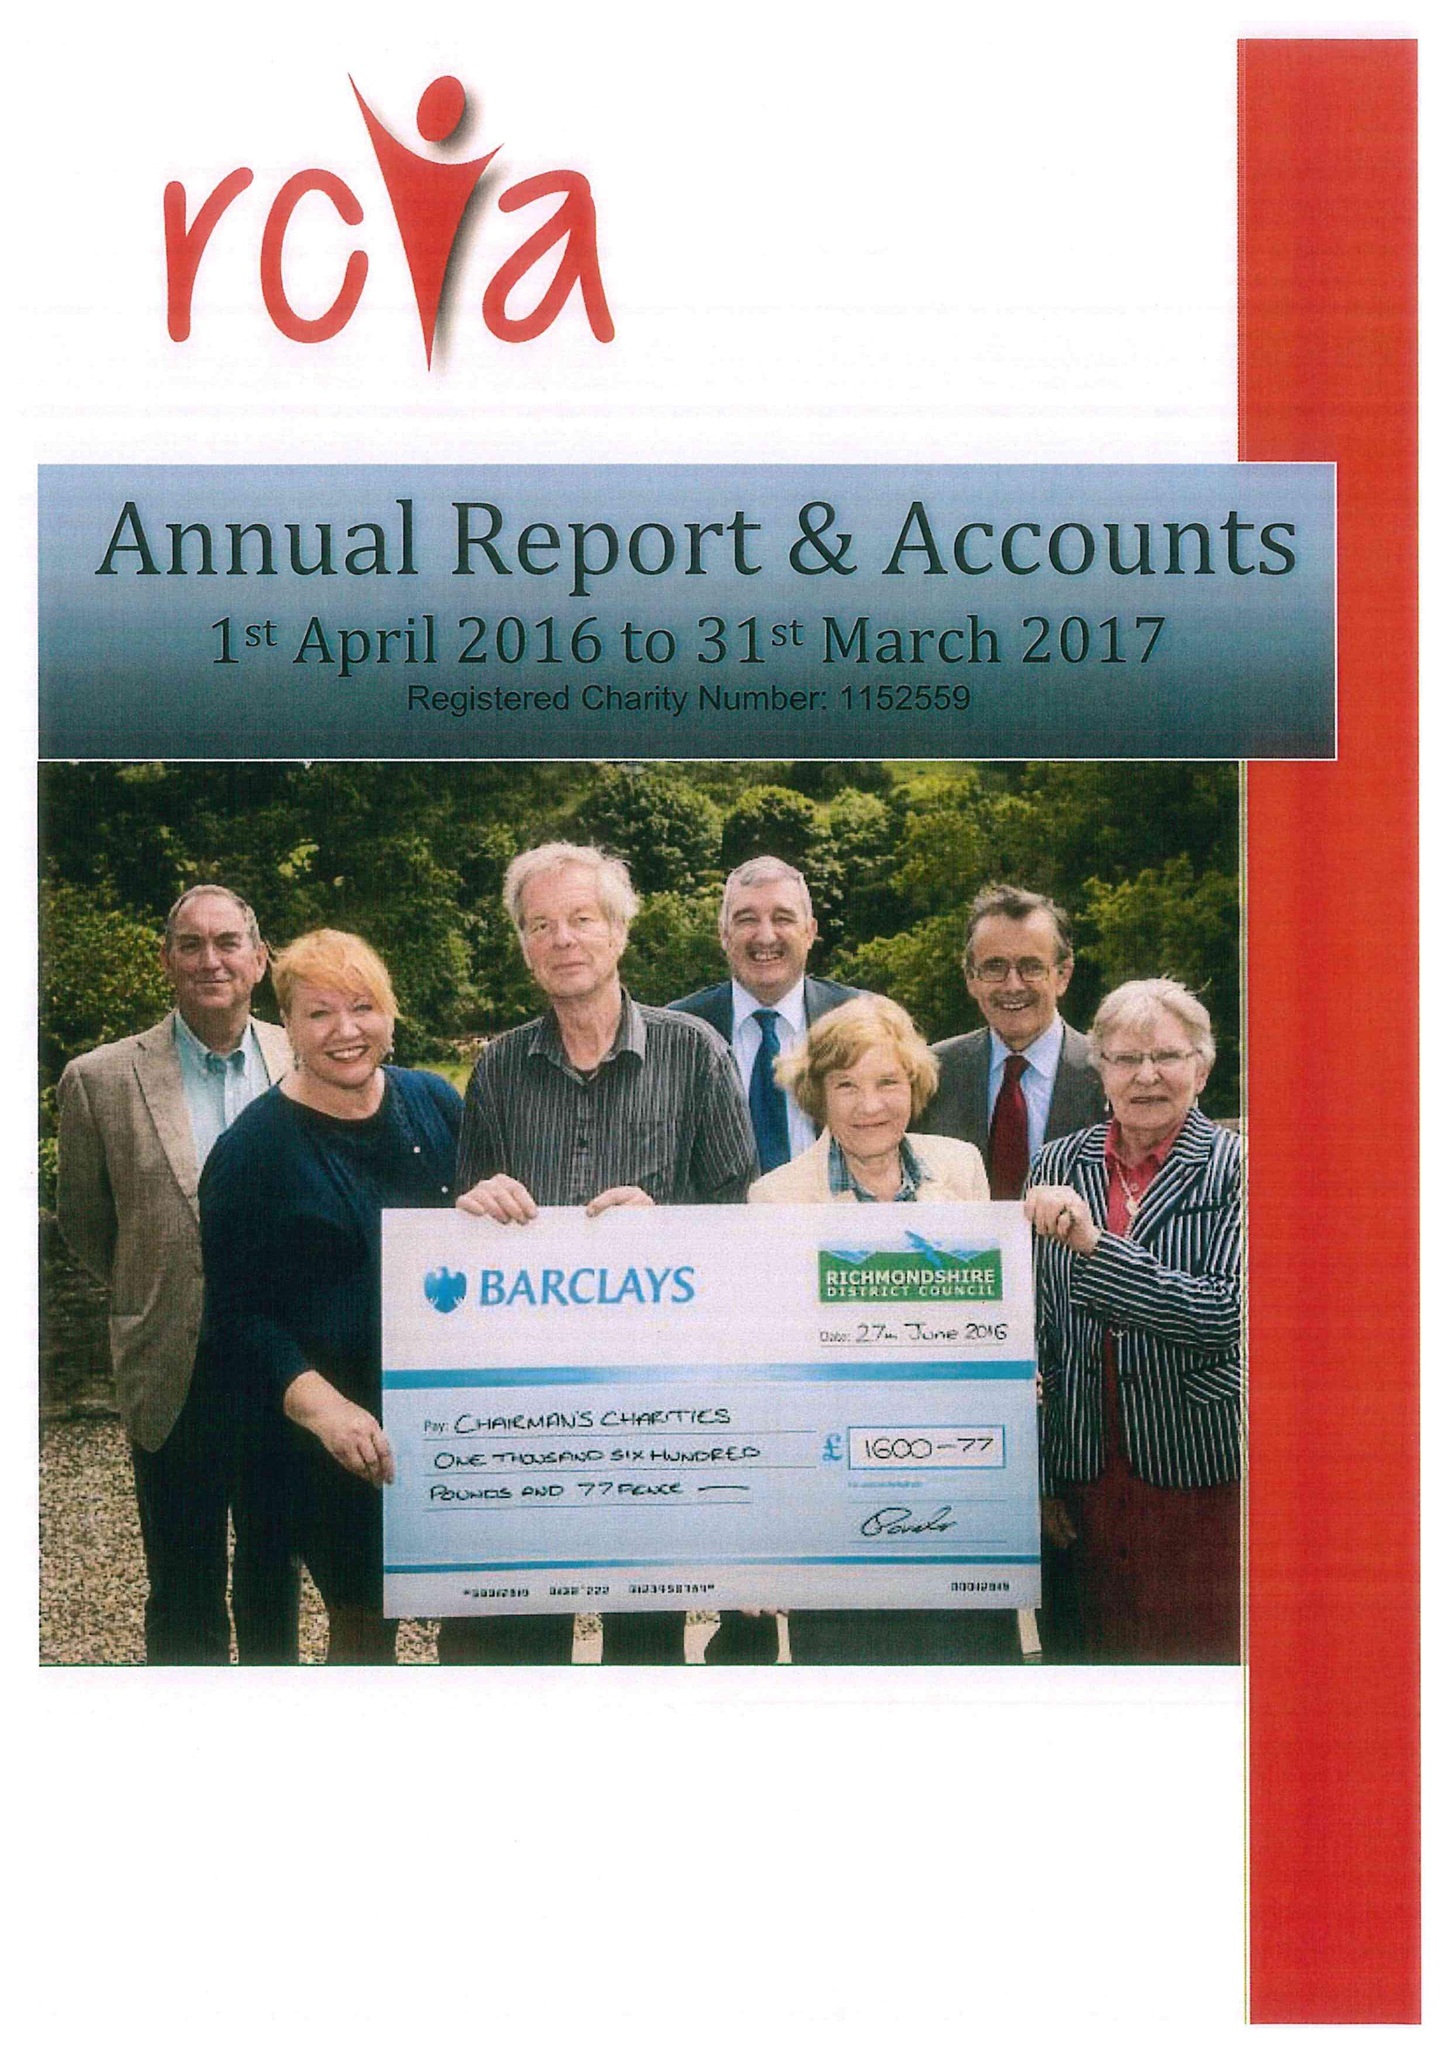What is the value for the address__postcode?
Answer the question using a single word or phrase. DL9 4AF 